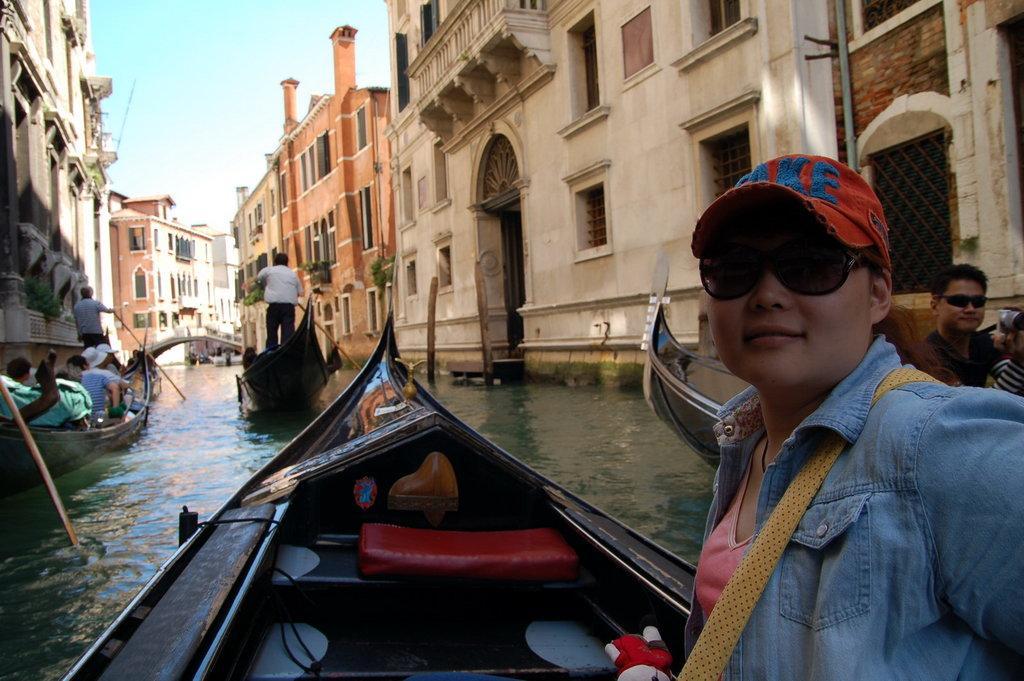Can you describe this image briefly? In the foreground of the image we can see a woman wearing a dress, goggles and a cap are sitting in a boat. On the left side of the image we can see group of people in a boat in the water. one person is standing. On the right side of the image we can see a person wearing goggles. In the center of the image we can see a person standing and holding a stick in his hand. In the background, we can see a group of buildings with windows and the sky. 